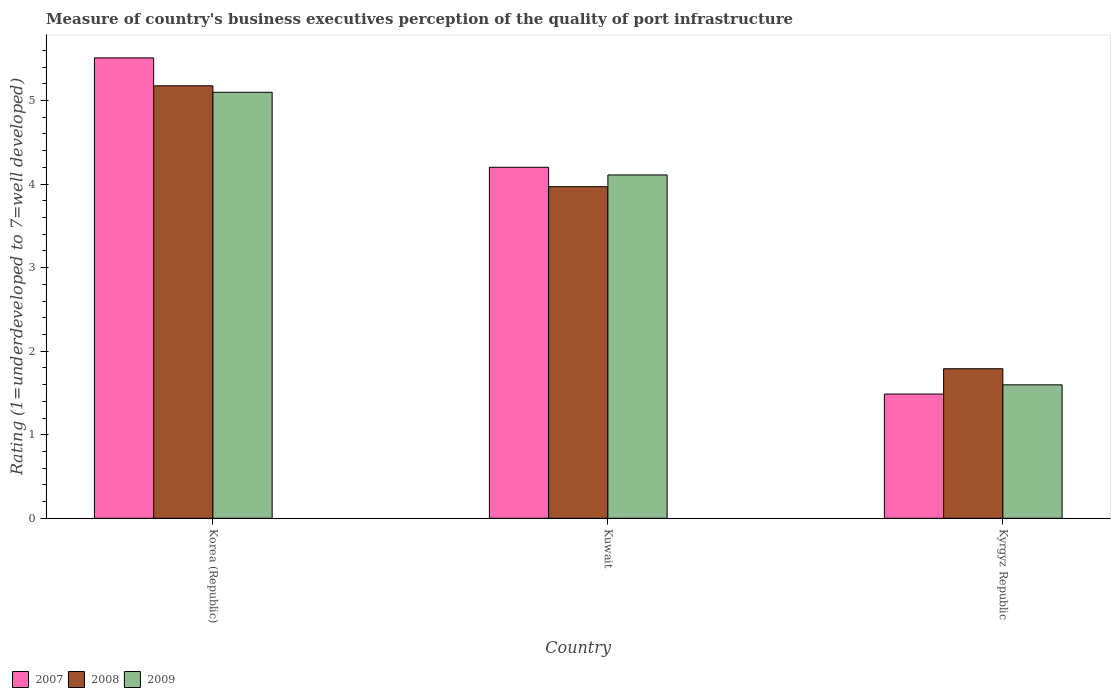How many different coloured bars are there?
Ensure brevity in your answer.  3. Are the number of bars per tick equal to the number of legend labels?
Provide a short and direct response. Yes. Are the number of bars on each tick of the X-axis equal?
Give a very brief answer. Yes. How many bars are there on the 1st tick from the left?
Your response must be concise. 3. What is the label of the 3rd group of bars from the left?
Ensure brevity in your answer.  Kyrgyz Republic. In how many cases, is the number of bars for a given country not equal to the number of legend labels?
Offer a terse response. 0. What is the ratings of the quality of port infrastructure in 2008 in Korea (Republic)?
Offer a very short reply. 5.18. Across all countries, what is the maximum ratings of the quality of port infrastructure in 2008?
Give a very brief answer. 5.18. Across all countries, what is the minimum ratings of the quality of port infrastructure in 2009?
Offer a terse response. 1.6. In which country was the ratings of the quality of port infrastructure in 2009 maximum?
Your answer should be very brief. Korea (Republic). In which country was the ratings of the quality of port infrastructure in 2008 minimum?
Your answer should be compact. Kyrgyz Republic. What is the total ratings of the quality of port infrastructure in 2008 in the graph?
Offer a very short reply. 10.93. What is the difference between the ratings of the quality of port infrastructure in 2009 in Kuwait and that in Kyrgyz Republic?
Your response must be concise. 2.51. What is the difference between the ratings of the quality of port infrastructure in 2008 in Kyrgyz Republic and the ratings of the quality of port infrastructure in 2009 in Kuwait?
Make the answer very short. -2.32. What is the average ratings of the quality of port infrastructure in 2008 per country?
Provide a succinct answer. 3.64. What is the difference between the ratings of the quality of port infrastructure of/in 2008 and ratings of the quality of port infrastructure of/in 2009 in Kyrgyz Republic?
Your answer should be compact. 0.19. What is the ratio of the ratings of the quality of port infrastructure in 2008 in Korea (Republic) to that in Kuwait?
Your response must be concise. 1.3. Is the ratings of the quality of port infrastructure in 2007 in Korea (Republic) less than that in Kuwait?
Make the answer very short. No. What is the difference between the highest and the second highest ratings of the quality of port infrastructure in 2009?
Give a very brief answer. -2.51. What is the difference between the highest and the lowest ratings of the quality of port infrastructure in 2009?
Your response must be concise. 3.5. In how many countries, is the ratings of the quality of port infrastructure in 2009 greater than the average ratings of the quality of port infrastructure in 2009 taken over all countries?
Offer a very short reply. 2. What does the 3rd bar from the right in Kuwait represents?
Offer a very short reply. 2007. Is it the case that in every country, the sum of the ratings of the quality of port infrastructure in 2009 and ratings of the quality of port infrastructure in 2008 is greater than the ratings of the quality of port infrastructure in 2007?
Provide a succinct answer. Yes. How many bars are there?
Give a very brief answer. 9. Are all the bars in the graph horizontal?
Provide a short and direct response. No. How many countries are there in the graph?
Make the answer very short. 3. Does the graph contain any zero values?
Provide a short and direct response. No. Where does the legend appear in the graph?
Your answer should be very brief. Bottom left. How are the legend labels stacked?
Give a very brief answer. Horizontal. What is the title of the graph?
Make the answer very short. Measure of country's business executives perception of the quality of port infrastructure. What is the label or title of the X-axis?
Offer a very short reply. Country. What is the label or title of the Y-axis?
Provide a short and direct response. Rating (1=underdeveloped to 7=well developed). What is the Rating (1=underdeveloped to 7=well developed) of 2007 in Korea (Republic)?
Provide a succinct answer. 5.51. What is the Rating (1=underdeveloped to 7=well developed) of 2008 in Korea (Republic)?
Give a very brief answer. 5.18. What is the Rating (1=underdeveloped to 7=well developed) of 2009 in Korea (Republic)?
Your answer should be very brief. 5.1. What is the Rating (1=underdeveloped to 7=well developed) in 2007 in Kuwait?
Give a very brief answer. 4.2. What is the Rating (1=underdeveloped to 7=well developed) in 2008 in Kuwait?
Keep it short and to the point. 3.97. What is the Rating (1=underdeveloped to 7=well developed) of 2009 in Kuwait?
Your response must be concise. 4.11. What is the Rating (1=underdeveloped to 7=well developed) in 2007 in Kyrgyz Republic?
Offer a terse response. 1.49. What is the Rating (1=underdeveloped to 7=well developed) of 2008 in Kyrgyz Republic?
Ensure brevity in your answer.  1.79. What is the Rating (1=underdeveloped to 7=well developed) in 2009 in Kyrgyz Republic?
Ensure brevity in your answer.  1.6. Across all countries, what is the maximum Rating (1=underdeveloped to 7=well developed) of 2007?
Provide a short and direct response. 5.51. Across all countries, what is the maximum Rating (1=underdeveloped to 7=well developed) in 2008?
Provide a short and direct response. 5.18. Across all countries, what is the maximum Rating (1=underdeveloped to 7=well developed) of 2009?
Give a very brief answer. 5.1. Across all countries, what is the minimum Rating (1=underdeveloped to 7=well developed) of 2007?
Your answer should be very brief. 1.49. Across all countries, what is the minimum Rating (1=underdeveloped to 7=well developed) of 2008?
Your answer should be very brief. 1.79. Across all countries, what is the minimum Rating (1=underdeveloped to 7=well developed) in 2009?
Offer a very short reply. 1.6. What is the total Rating (1=underdeveloped to 7=well developed) in 2007 in the graph?
Make the answer very short. 11.2. What is the total Rating (1=underdeveloped to 7=well developed) in 2008 in the graph?
Offer a very short reply. 10.93. What is the total Rating (1=underdeveloped to 7=well developed) in 2009 in the graph?
Provide a short and direct response. 10.8. What is the difference between the Rating (1=underdeveloped to 7=well developed) in 2007 in Korea (Republic) and that in Kuwait?
Give a very brief answer. 1.31. What is the difference between the Rating (1=underdeveloped to 7=well developed) in 2008 in Korea (Republic) and that in Kuwait?
Offer a very short reply. 1.21. What is the difference between the Rating (1=underdeveloped to 7=well developed) of 2009 in Korea (Republic) and that in Kuwait?
Your answer should be very brief. 0.99. What is the difference between the Rating (1=underdeveloped to 7=well developed) in 2007 in Korea (Republic) and that in Kyrgyz Republic?
Your answer should be very brief. 4.02. What is the difference between the Rating (1=underdeveloped to 7=well developed) in 2008 in Korea (Republic) and that in Kyrgyz Republic?
Offer a very short reply. 3.39. What is the difference between the Rating (1=underdeveloped to 7=well developed) of 2009 in Korea (Republic) and that in Kyrgyz Republic?
Make the answer very short. 3.5. What is the difference between the Rating (1=underdeveloped to 7=well developed) in 2007 in Kuwait and that in Kyrgyz Republic?
Keep it short and to the point. 2.71. What is the difference between the Rating (1=underdeveloped to 7=well developed) in 2008 in Kuwait and that in Kyrgyz Republic?
Your response must be concise. 2.18. What is the difference between the Rating (1=underdeveloped to 7=well developed) of 2009 in Kuwait and that in Kyrgyz Republic?
Ensure brevity in your answer.  2.51. What is the difference between the Rating (1=underdeveloped to 7=well developed) of 2007 in Korea (Republic) and the Rating (1=underdeveloped to 7=well developed) of 2008 in Kuwait?
Ensure brevity in your answer.  1.54. What is the difference between the Rating (1=underdeveloped to 7=well developed) of 2007 in Korea (Republic) and the Rating (1=underdeveloped to 7=well developed) of 2009 in Kuwait?
Your response must be concise. 1.4. What is the difference between the Rating (1=underdeveloped to 7=well developed) in 2008 in Korea (Republic) and the Rating (1=underdeveloped to 7=well developed) in 2009 in Kuwait?
Offer a very short reply. 1.07. What is the difference between the Rating (1=underdeveloped to 7=well developed) in 2007 in Korea (Republic) and the Rating (1=underdeveloped to 7=well developed) in 2008 in Kyrgyz Republic?
Make the answer very short. 3.72. What is the difference between the Rating (1=underdeveloped to 7=well developed) in 2007 in Korea (Republic) and the Rating (1=underdeveloped to 7=well developed) in 2009 in Kyrgyz Republic?
Provide a succinct answer. 3.91. What is the difference between the Rating (1=underdeveloped to 7=well developed) of 2008 in Korea (Republic) and the Rating (1=underdeveloped to 7=well developed) of 2009 in Kyrgyz Republic?
Your answer should be very brief. 3.58. What is the difference between the Rating (1=underdeveloped to 7=well developed) of 2007 in Kuwait and the Rating (1=underdeveloped to 7=well developed) of 2008 in Kyrgyz Republic?
Your answer should be very brief. 2.41. What is the difference between the Rating (1=underdeveloped to 7=well developed) of 2007 in Kuwait and the Rating (1=underdeveloped to 7=well developed) of 2009 in Kyrgyz Republic?
Offer a very short reply. 2.6. What is the difference between the Rating (1=underdeveloped to 7=well developed) in 2008 in Kuwait and the Rating (1=underdeveloped to 7=well developed) in 2009 in Kyrgyz Republic?
Provide a short and direct response. 2.37. What is the average Rating (1=underdeveloped to 7=well developed) in 2007 per country?
Provide a succinct answer. 3.73. What is the average Rating (1=underdeveloped to 7=well developed) in 2008 per country?
Provide a succinct answer. 3.64. What is the average Rating (1=underdeveloped to 7=well developed) of 2009 per country?
Keep it short and to the point. 3.6. What is the difference between the Rating (1=underdeveloped to 7=well developed) in 2007 and Rating (1=underdeveloped to 7=well developed) in 2008 in Korea (Republic)?
Your answer should be very brief. 0.33. What is the difference between the Rating (1=underdeveloped to 7=well developed) in 2007 and Rating (1=underdeveloped to 7=well developed) in 2009 in Korea (Republic)?
Offer a very short reply. 0.41. What is the difference between the Rating (1=underdeveloped to 7=well developed) of 2008 and Rating (1=underdeveloped to 7=well developed) of 2009 in Korea (Republic)?
Offer a terse response. 0.08. What is the difference between the Rating (1=underdeveloped to 7=well developed) in 2007 and Rating (1=underdeveloped to 7=well developed) in 2008 in Kuwait?
Your answer should be compact. 0.23. What is the difference between the Rating (1=underdeveloped to 7=well developed) of 2007 and Rating (1=underdeveloped to 7=well developed) of 2009 in Kuwait?
Provide a short and direct response. 0.09. What is the difference between the Rating (1=underdeveloped to 7=well developed) of 2008 and Rating (1=underdeveloped to 7=well developed) of 2009 in Kuwait?
Provide a short and direct response. -0.14. What is the difference between the Rating (1=underdeveloped to 7=well developed) of 2007 and Rating (1=underdeveloped to 7=well developed) of 2008 in Kyrgyz Republic?
Offer a very short reply. -0.3. What is the difference between the Rating (1=underdeveloped to 7=well developed) in 2007 and Rating (1=underdeveloped to 7=well developed) in 2009 in Kyrgyz Republic?
Make the answer very short. -0.11. What is the difference between the Rating (1=underdeveloped to 7=well developed) of 2008 and Rating (1=underdeveloped to 7=well developed) of 2009 in Kyrgyz Republic?
Make the answer very short. 0.19. What is the ratio of the Rating (1=underdeveloped to 7=well developed) of 2007 in Korea (Republic) to that in Kuwait?
Keep it short and to the point. 1.31. What is the ratio of the Rating (1=underdeveloped to 7=well developed) in 2008 in Korea (Republic) to that in Kuwait?
Keep it short and to the point. 1.3. What is the ratio of the Rating (1=underdeveloped to 7=well developed) of 2009 in Korea (Republic) to that in Kuwait?
Provide a short and direct response. 1.24. What is the ratio of the Rating (1=underdeveloped to 7=well developed) of 2007 in Korea (Republic) to that in Kyrgyz Republic?
Ensure brevity in your answer.  3.71. What is the ratio of the Rating (1=underdeveloped to 7=well developed) of 2008 in Korea (Republic) to that in Kyrgyz Republic?
Your response must be concise. 2.89. What is the ratio of the Rating (1=underdeveloped to 7=well developed) in 2009 in Korea (Republic) to that in Kyrgyz Republic?
Your response must be concise. 3.19. What is the ratio of the Rating (1=underdeveloped to 7=well developed) in 2007 in Kuwait to that in Kyrgyz Republic?
Provide a short and direct response. 2.83. What is the ratio of the Rating (1=underdeveloped to 7=well developed) of 2008 in Kuwait to that in Kyrgyz Republic?
Your response must be concise. 2.22. What is the ratio of the Rating (1=underdeveloped to 7=well developed) in 2009 in Kuwait to that in Kyrgyz Republic?
Your answer should be very brief. 2.57. What is the difference between the highest and the second highest Rating (1=underdeveloped to 7=well developed) in 2007?
Your response must be concise. 1.31. What is the difference between the highest and the second highest Rating (1=underdeveloped to 7=well developed) of 2008?
Offer a very short reply. 1.21. What is the difference between the highest and the lowest Rating (1=underdeveloped to 7=well developed) of 2007?
Your response must be concise. 4.02. What is the difference between the highest and the lowest Rating (1=underdeveloped to 7=well developed) in 2008?
Offer a very short reply. 3.39. What is the difference between the highest and the lowest Rating (1=underdeveloped to 7=well developed) in 2009?
Your answer should be very brief. 3.5. 